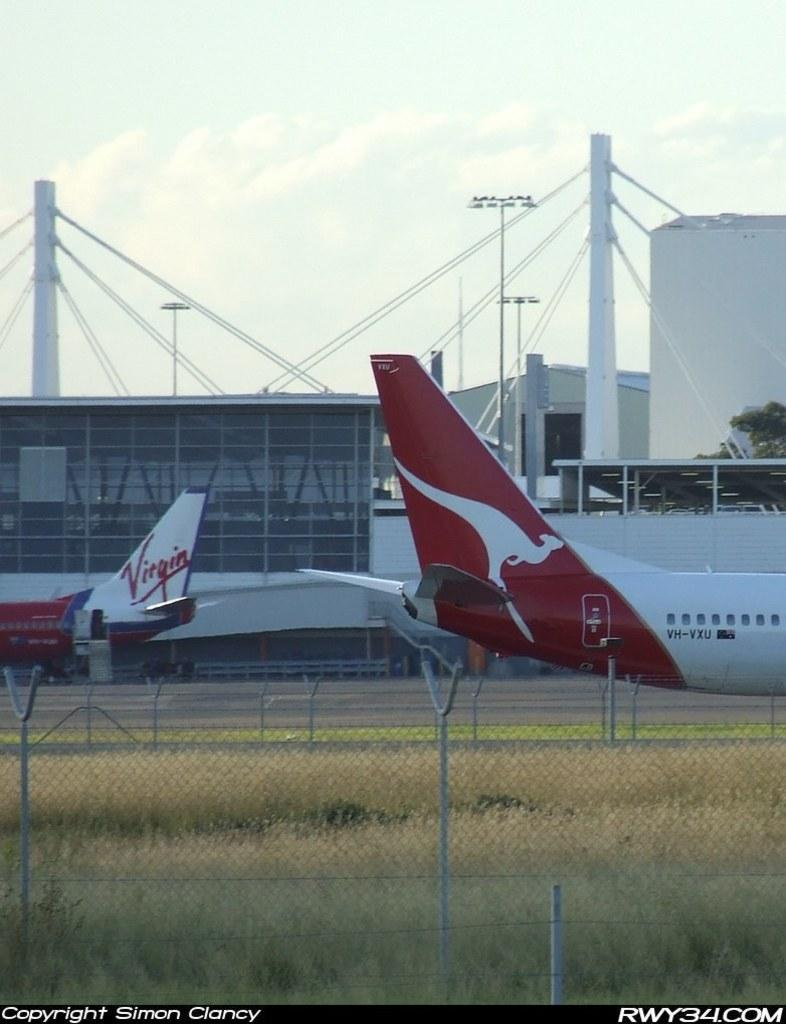<image>
Give a short and clear explanation of the subsequent image. A virgin airplane is parked on a runway. 